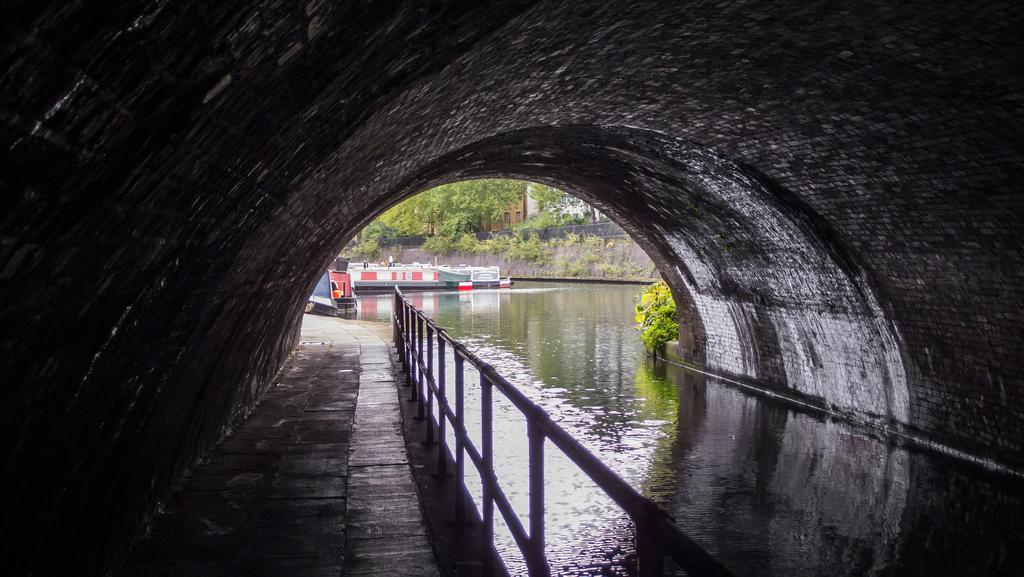What is the main subject in the center of the image? There is a tunnel in the center of the image. What can be seen on the sides of the tunnel? There is a fence visible in the image. What is visible beyond the tunnel? Trees, buildings, and a few other objects are visible through the tunnel. Is there any water visible in the image? Yes, water is visible in the image. Can you tell me how many family members are visible through the tunnel in the image? There is no family visible through the tunnel in the image. What type of screw is being used to hold the fence together in the image? There is no screw visible in the image; it is a fence made of a different material. 